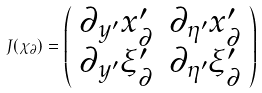<formula> <loc_0><loc_0><loc_500><loc_500>J ( \chi _ { \partial } ) = \left ( \begin{array} { c c } \partial _ { y ^ { \prime } } x ^ { \prime } _ { \partial } & \partial _ { \eta ^ { \prime } } x ^ { \prime } _ { \partial } \\ \partial _ { y ^ { \prime } } \xi ^ { \prime } _ { \partial } & \partial _ { \eta ^ { \prime } } \xi ^ { \prime } _ { \partial } \end{array} \right )</formula> 